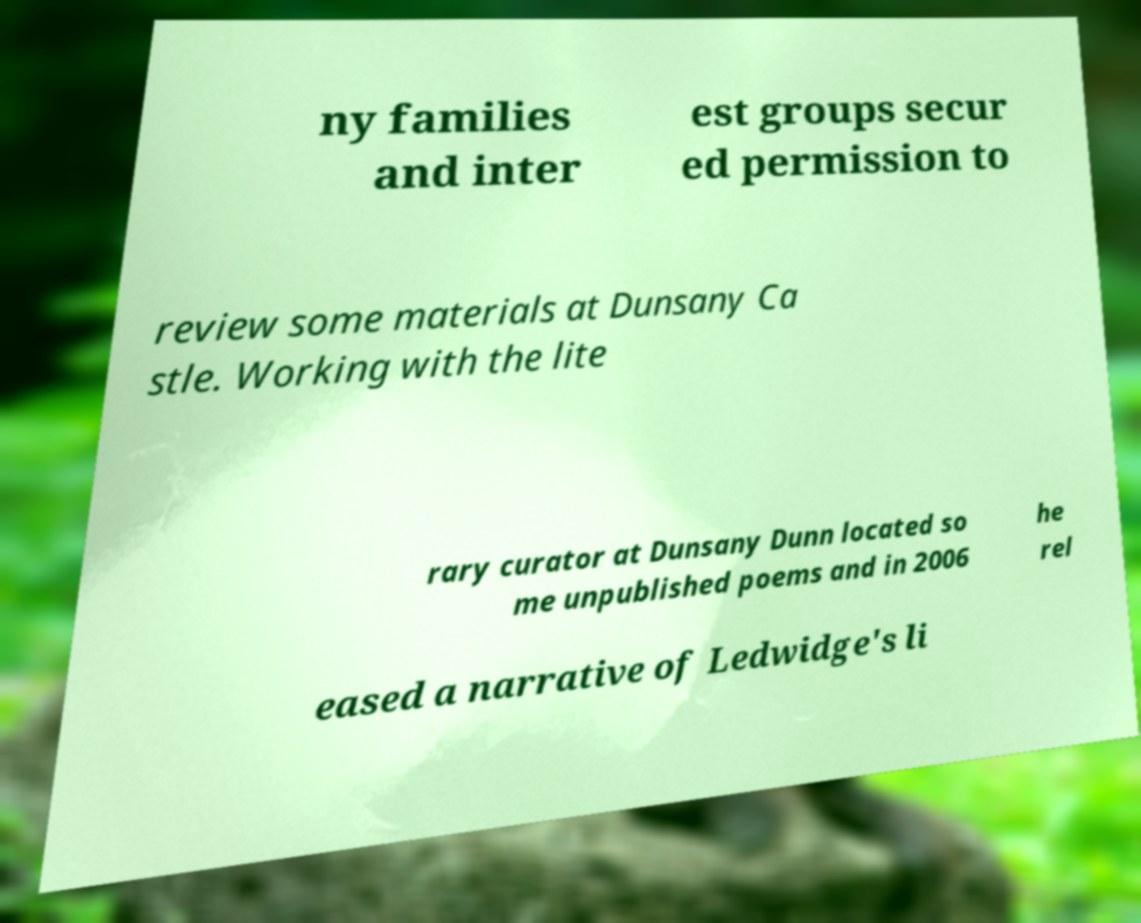For documentation purposes, I need the text within this image transcribed. Could you provide that? ny families and inter est groups secur ed permission to review some materials at Dunsany Ca stle. Working with the lite rary curator at Dunsany Dunn located so me unpublished poems and in 2006 he rel eased a narrative of Ledwidge's li 